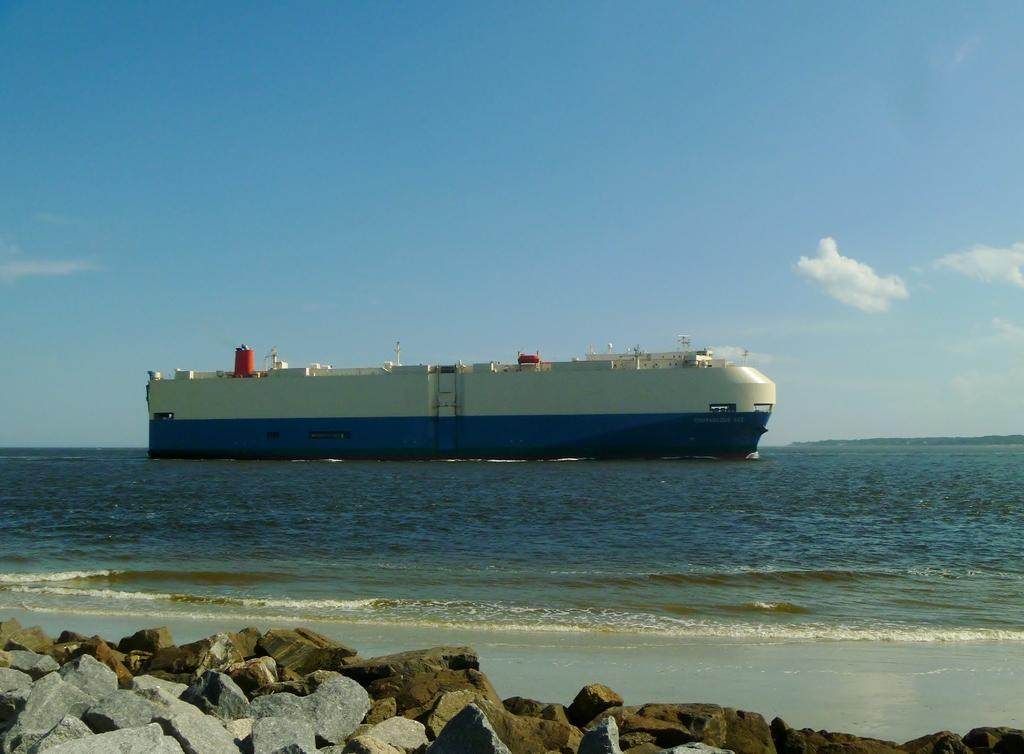Can you describe this image briefly? In the background we can see the clear blue sky with clouds. In this picture we can see the ship and water. Near to the sea shore we can see stones. 